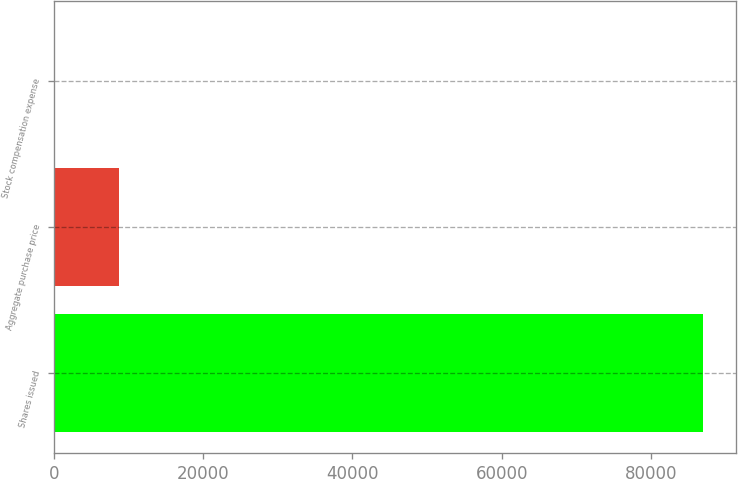<chart> <loc_0><loc_0><loc_500><loc_500><bar_chart><fcel>Shares issued<fcel>Aggregate purchase price<fcel>Stock compensation expense<nl><fcel>87000<fcel>8700.36<fcel>0.4<nl></chart> 